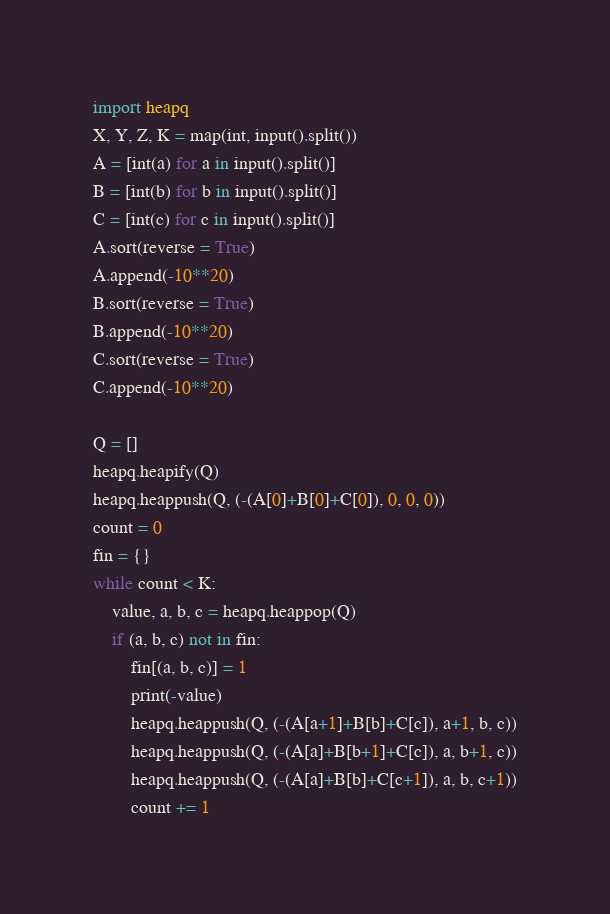Convert code to text. <code><loc_0><loc_0><loc_500><loc_500><_Python_>import heapq
X, Y, Z, K = map(int, input().split())
A = [int(a) for a in input().split()]
B = [int(b) for b in input().split()]
C = [int(c) for c in input().split()]
A.sort(reverse = True)
A.append(-10**20)
B.sort(reverse = True)
B.append(-10**20)
C.sort(reverse = True)
C.append(-10**20)

Q = []
heapq.heapify(Q)
heapq.heappush(Q, (-(A[0]+B[0]+C[0]), 0, 0, 0))
count = 0
fin = {}
while count < K:
    value, a, b, c = heapq.heappop(Q)
    if (a, b, c) not in fin:
        fin[(a, b, c)] = 1
        print(-value)
        heapq.heappush(Q, (-(A[a+1]+B[b]+C[c]), a+1, b, c))
        heapq.heappush(Q, (-(A[a]+B[b+1]+C[c]), a, b+1, c))
        heapq.heappush(Q, (-(A[a]+B[b]+C[c+1]), a, b, c+1))
        count += 1

</code> 